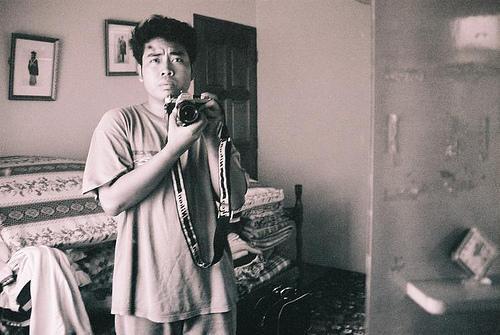How many people are in the pictures on the wall?
Give a very brief answer. 2. 